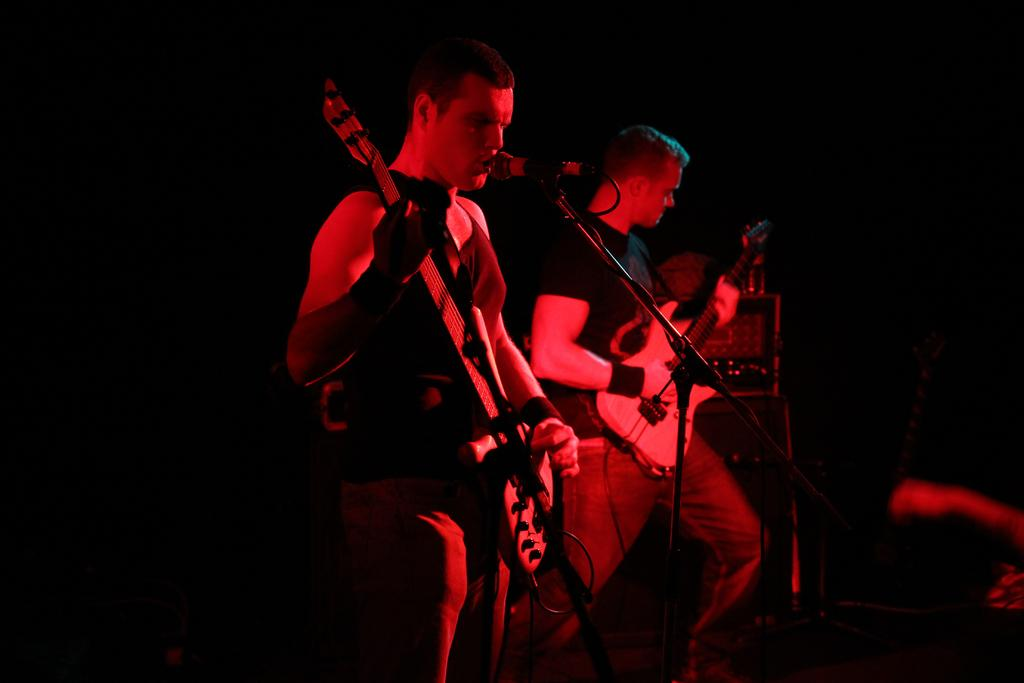How many people are in the image? There are two men in the image. What are the men doing in the image? The men are playing the guitar. What object is present in front of the men? There is a microphone (mic) in front of the men. What type of goat can be seen playing the guitar in the image? There is no goat present in the image, and the men are the ones playing the guitar. What fruit is being used as a prop in the image? There is no fruit present in the image. 